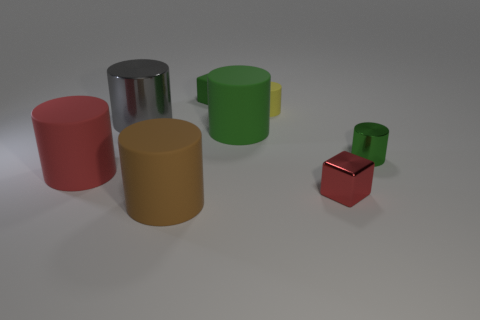Do the red object left of the tiny red cube and the red object that is to the right of the large brown rubber object have the same material?
Your response must be concise. No. What is the shape of the red object that is on the right side of the large rubber thing left of the brown cylinder?
Provide a succinct answer. Cube. The tiny block that is the same material as the brown thing is what color?
Offer a terse response. Green. Does the tiny shiny block have the same color as the small metal cylinder?
Provide a succinct answer. No. What shape is the rubber object that is the same size as the yellow matte cylinder?
Keep it short and to the point. Cube. What size is the red rubber object?
Your response must be concise. Large. Does the cylinder right of the tiny metal block have the same size as the green cylinder that is to the left of the tiny green metallic cylinder?
Keep it short and to the point. No. What color is the large rubber thing right of the matte cylinder in front of the large red rubber cylinder?
Provide a succinct answer. Green. There is a red cylinder that is the same size as the brown matte cylinder; what is its material?
Your answer should be very brief. Rubber. How many metal things are either cyan spheres or cylinders?
Provide a short and direct response. 2. 